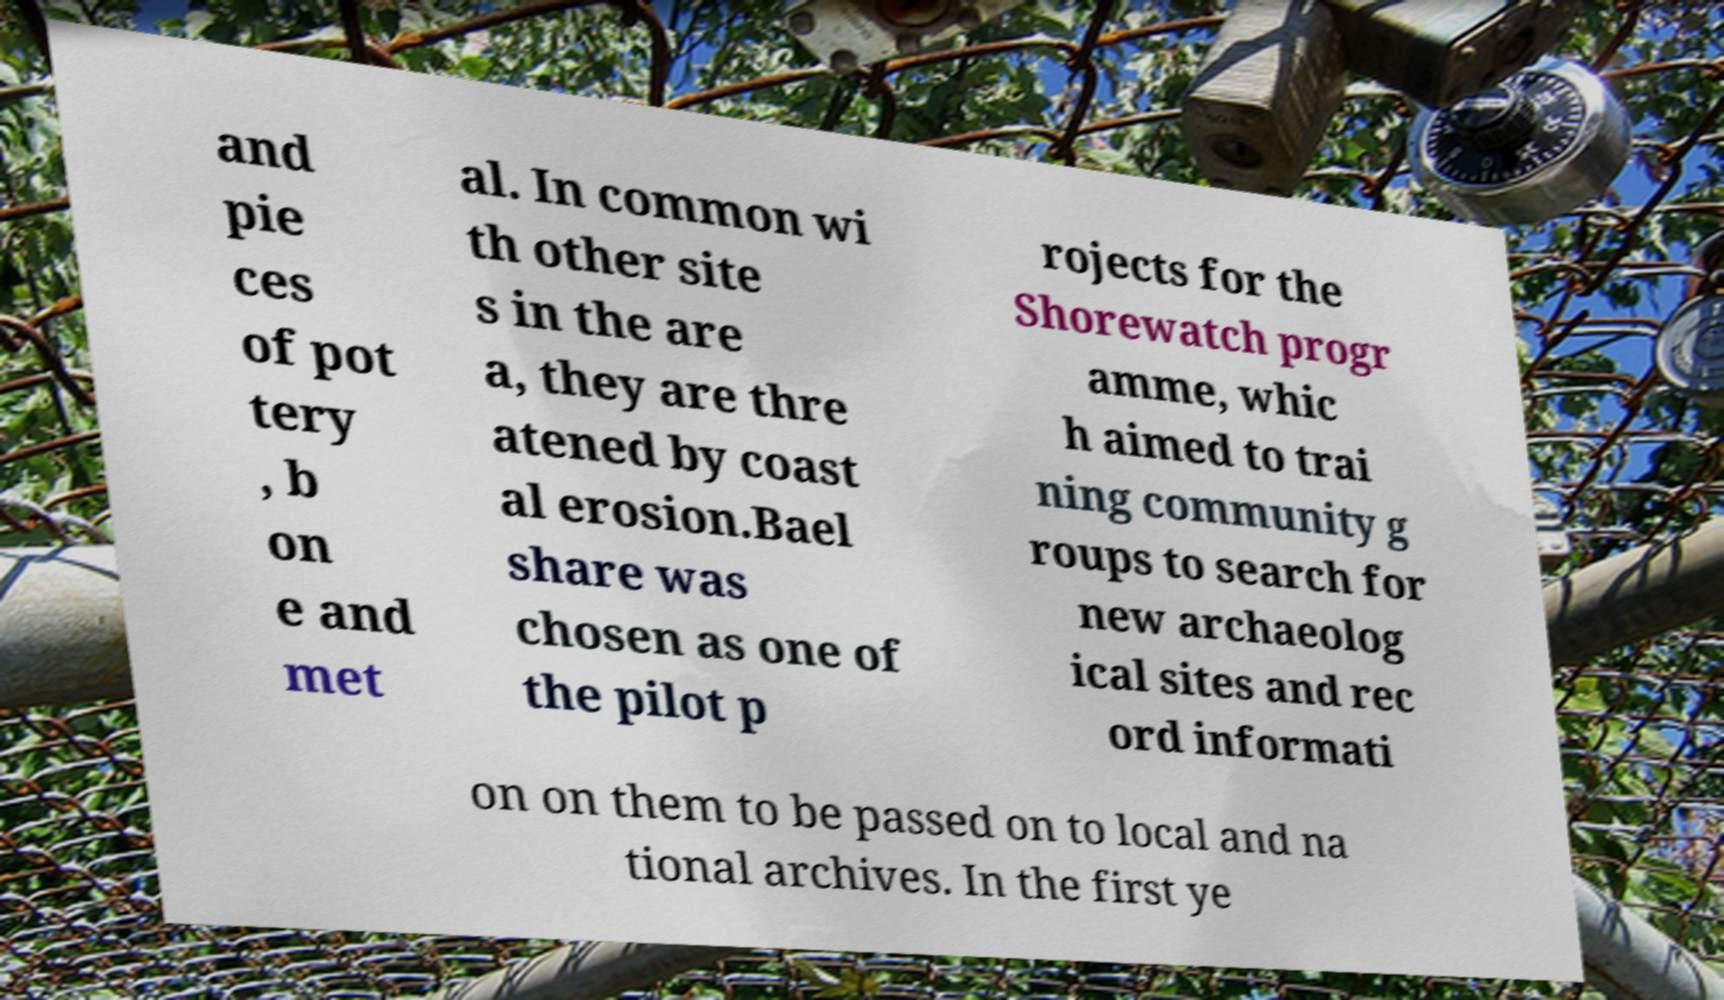Could you extract and type out the text from this image? and pie ces of pot tery , b on e and met al. In common wi th other site s in the are a, they are thre atened by coast al erosion.Bael share was chosen as one of the pilot p rojects for the Shorewatch progr amme, whic h aimed to trai ning community g roups to search for new archaeolog ical sites and rec ord informati on on them to be passed on to local and na tional archives. In the first ye 